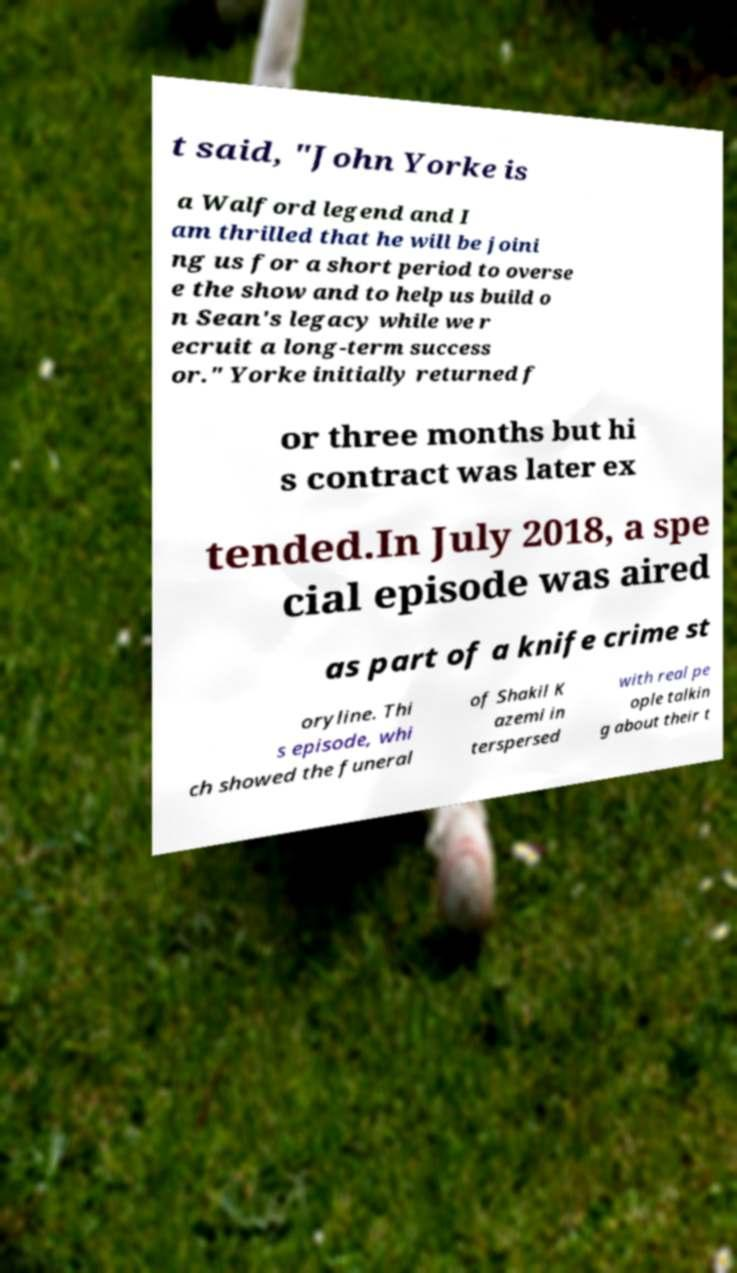Please identify and transcribe the text found in this image. t said, "John Yorke is a Walford legend and I am thrilled that he will be joini ng us for a short period to overse e the show and to help us build o n Sean's legacy while we r ecruit a long-term success or." Yorke initially returned f or three months but hi s contract was later ex tended.In July 2018, a spe cial episode was aired as part of a knife crime st oryline. Thi s episode, whi ch showed the funeral of Shakil K azemi in terspersed with real pe ople talkin g about their t 